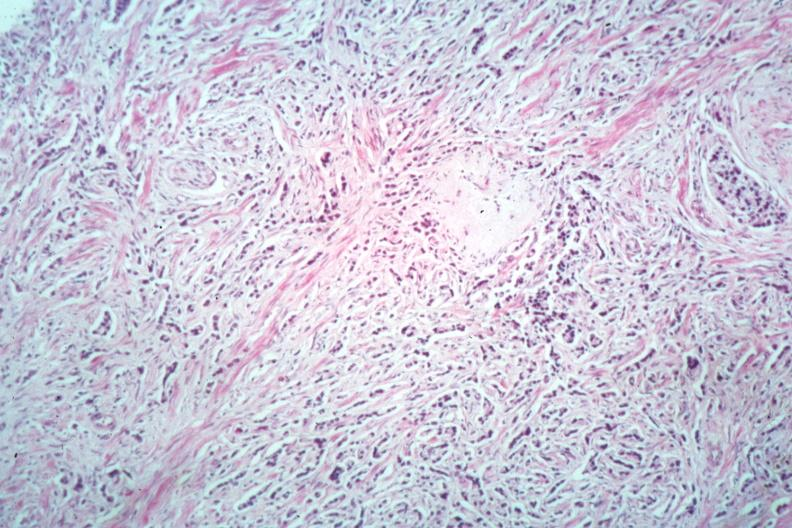what does this image show?
Answer the question using a single word or phrase. Diffusely infiltrating small cell carcinoma readily seen 